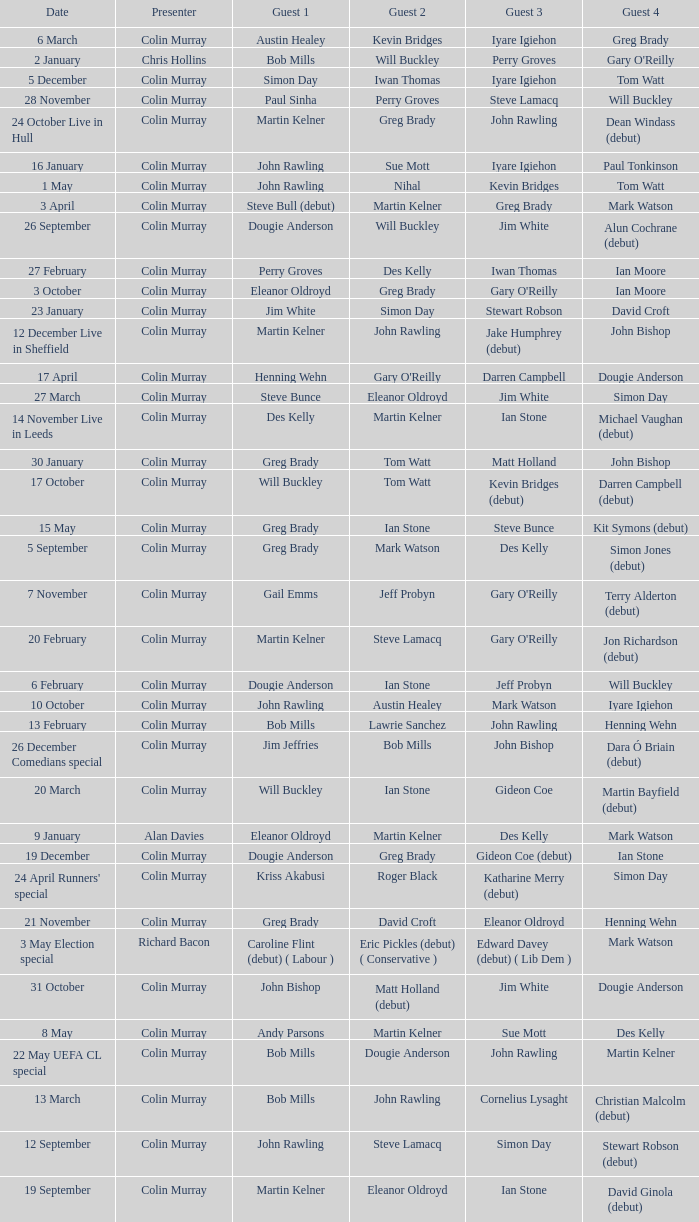On episodes where guest 1 is Jim White, who was guest 3? Stewart Robson. 